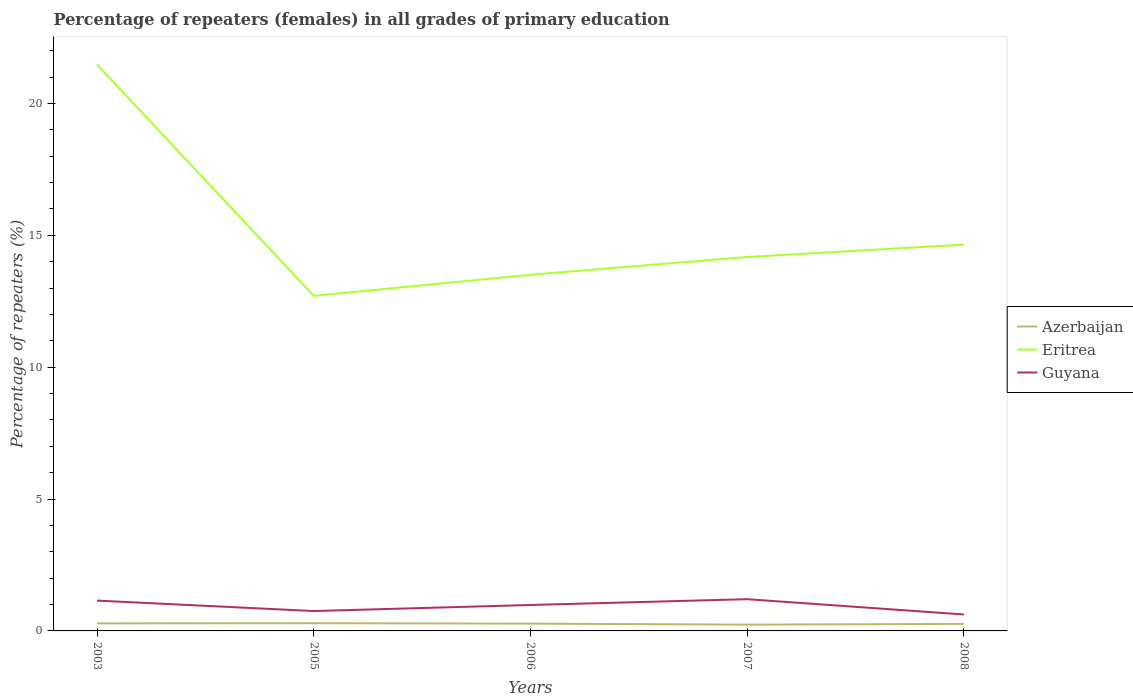How many different coloured lines are there?
Make the answer very short. 3. Is the number of lines equal to the number of legend labels?
Give a very brief answer. Yes. Across all years, what is the maximum percentage of repeaters (females) in Eritrea?
Keep it short and to the point. 12.7. In which year was the percentage of repeaters (females) in Azerbaijan maximum?
Provide a succinct answer. 2007. What is the total percentage of repeaters (females) in Azerbaijan in the graph?
Your answer should be very brief. -0.01. What is the difference between the highest and the second highest percentage of repeaters (females) in Azerbaijan?
Your response must be concise. 0.06. What is the difference between the highest and the lowest percentage of repeaters (females) in Eritrea?
Offer a very short reply. 1. How many lines are there?
Your response must be concise. 3. How many years are there in the graph?
Give a very brief answer. 5. Does the graph contain any zero values?
Provide a short and direct response. No. What is the title of the graph?
Your answer should be very brief. Percentage of repeaters (females) in all grades of primary education. What is the label or title of the X-axis?
Your answer should be very brief. Years. What is the label or title of the Y-axis?
Give a very brief answer. Percentage of repeaters (%). What is the Percentage of repeaters (%) of Azerbaijan in 2003?
Your answer should be compact. 0.29. What is the Percentage of repeaters (%) of Eritrea in 2003?
Offer a terse response. 21.47. What is the Percentage of repeaters (%) of Guyana in 2003?
Ensure brevity in your answer.  1.15. What is the Percentage of repeaters (%) of Azerbaijan in 2005?
Offer a very short reply. 0.29. What is the Percentage of repeaters (%) of Eritrea in 2005?
Offer a terse response. 12.7. What is the Percentage of repeaters (%) of Guyana in 2005?
Your answer should be compact. 0.75. What is the Percentage of repeaters (%) in Azerbaijan in 2006?
Your response must be concise. 0.28. What is the Percentage of repeaters (%) of Eritrea in 2006?
Offer a terse response. 13.5. What is the Percentage of repeaters (%) of Guyana in 2006?
Make the answer very short. 0.98. What is the Percentage of repeaters (%) of Azerbaijan in 2007?
Provide a succinct answer. 0.24. What is the Percentage of repeaters (%) of Eritrea in 2007?
Give a very brief answer. 14.18. What is the Percentage of repeaters (%) of Guyana in 2007?
Provide a succinct answer. 1.2. What is the Percentage of repeaters (%) in Azerbaijan in 2008?
Offer a very short reply. 0.27. What is the Percentage of repeaters (%) of Eritrea in 2008?
Your answer should be compact. 14.65. What is the Percentage of repeaters (%) in Guyana in 2008?
Keep it short and to the point. 0.62. Across all years, what is the maximum Percentage of repeaters (%) of Azerbaijan?
Keep it short and to the point. 0.29. Across all years, what is the maximum Percentage of repeaters (%) in Eritrea?
Provide a succinct answer. 21.47. Across all years, what is the maximum Percentage of repeaters (%) in Guyana?
Your answer should be compact. 1.2. Across all years, what is the minimum Percentage of repeaters (%) of Azerbaijan?
Give a very brief answer. 0.24. Across all years, what is the minimum Percentage of repeaters (%) in Eritrea?
Keep it short and to the point. 12.7. Across all years, what is the minimum Percentage of repeaters (%) in Guyana?
Offer a very short reply. 0.62. What is the total Percentage of repeaters (%) in Azerbaijan in the graph?
Provide a succinct answer. 1.36. What is the total Percentage of repeaters (%) of Eritrea in the graph?
Provide a short and direct response. 76.5. What is the total Percentage of repeaters (%) in Guyana in the graph?
Your response must be concise. 4.71. What is the difference between the Percentage of repeaters (%) of Azerbaijan in 2003 and that in 2005?
Make the answer very short. -0.01. What is the difference between the Percentage of repeaters (%) of Eritrea in 2003 and that in 2005?
Your answer should be very brief. 8.77. What is the difference between the Percentage of repeaters (%) in Guyana in 2003 and that in 2005?
Your answer should be very brief. 0.4. What is the difference between the Percentage of repeaters (%) of Azerbaijan in 2003 and that in 2006?
Make the answer very short. 0.01. What is the difference between the Percentage of repeaters (%) in Eritrea in 2003 and that in 2006?
Offer a terse response. 7.97. What is the difference between the Percentage of repeaters (%) of Guyana in 2003 and that in 2006?
Offer a terse response. 0.17. What is the difference between the Percentage of repeaters (%) in Azerbaijan in 2003 and that in 2007?
Give a very brief answer. 0.05. What is the difference between the Percentage of repeaters (%) in Eritrea in 2003 and that in 2007?
Keep it short and to the point. 7.29. What is the difference between the Percentage of repeaters (%) of Guyana in 2003 and that in 2007?
Ensure brevity in your answer.  -0.05. What is the difference between the Percentage of repeaters (%) in Azerbaijan in 2003 and that in 2008?
Your response must be concise. 0.02. What is the difference between the Percentage of repeaters (%) in Eritrea in 2003 and that in 2008?
Offer a terse response. 6.83. What is the difference between the Percentage of repeaters (%) in Guyana in 2003 and that in 2008?
Offer a terse response. 0.53. What is the difference between the Percentage of repeaters (%) of Azerbaijan in 2005 and that in 2006?
Your answer should be very brief. 0.02. What is the difference between the Percentage of repeaters (%) in Eritrea in 2005 and that in 2006?
Your answer should be compact. -0.8. What is the difference between the Percentage of repeaters (%) in Guyana in 2005 and that in 2006?
Your answer should be very brief. -0.23. What is the difference between the Percentage of repeaters (%) in Azerbaijan in 2005 and that in 2007?
Your answer should be very brief. 0.06. What is the difference between the Percentage of repeaters (%) in Eritrea in 2005 and that in 2007?
Ensure brevity in your answer.  -1.47. What is the difference between the Percentage of repeaters (%) of Guyana in 2005 and that in 2007?
Provide a succinct answer. -0.45. What is the difference between the Percentage of repeaters (%) of Azerbaijan in 2005 and that in 2008?
Make the answer very short. 0.03. What is the difference between the Percentage of repeaters (%) in Eritrea in 2005 and that in 2008?
Make the answer very short. -1.94. What is the difference between the Percentage of repeaters (%) in Guyana in 2005 and that in 2008?
Give a very brief answer. 0.13. What is the difference between the Percentage of repeaters (%) of Azerbaijan in 2006 and that in 2007?
Provide a succinct answer. 0.04. What is the difference between the Percentage of repeaters (%) of Eritrea in 2006 and that in 2007?
Your response must be concise. -0.67. What is the difference between the Percentage of repeaters (%) in Guyana in 2006 and that in 2007?
Provide a succinct answer. -0.22. What is the difference between the Percentage of repeaters (%) in Azerbaijan in 2006 and that in 2008?
Keep it short and to the point. 0.01. What is the difference between the Percentage of repeaters (%) of Eritrea in 2006 and that in 2008?
Your answer should be very brief. -1.14. What is the difference between the Percentage of repeaters (%) in Guyana in 2006 and that in 2008?
Keep it short and to the point. 0.36. What is the difference between the Percentage of repeaters (%) of Azerbaijan in 2007 and that in 2008?
Your answer should be very brief. -0.03. What is the difference between the Percentage of repeaters (%) in Eritrea in 2007 and that in 2008?
Your answer should be compact. -0.47. What is the difference between the Percentage of repeaters (%) of Guyana in 2007 and that in 2008?
Provide a succinct answer. 0.58. What is the difference between the Percentage of repeaters (%) of Azerbaijan in 2003 and the Percentage of repeaters (%) of Eritrea in 2005?
Give a very brief answer. -12.42. What is the difference between the Percentage of repeaters (%) in Azerbaijan in 2003 and the Percentage of repeaters (%) in Guyana in 2005?
Your answer should be compact. -0.47. What is the difference between the Percentage of repeaters (%) of Eritrea in 2003 and the Percentage of repeaters (%) of Guyana in 2005?
Your response must be concise. 20.72. What is the difference between the Percentage of repeaters (%) of Azerbaijan in 2003 and the Percentage of repeaters (%) of Eritrea in 2006?
Your response must be concise. -13.22. What is the difference between the Percentage of repeaters (%) of Azerbaijan in 2003 and the Percentage of repeaters (%) of Guyana in 2006?
Your answer should be very brief. -0.7. What is the difference between the Percentage of repeaters (%) in Eritrea in 2003 and the Percentage of repeaters (%) in Guyana in 2006?
Provide a short and direct response. 20.49. What is the difference between the Percentage of repeaters (%) in Azerbaijan in 2003 and the Percentage of repeaters (%) in Eritrea in 2007?
Make the answer very short. -13.89. What is the difference between the Percentage of repeaters (%) of Azerbaijan in 2003 and the Percentage of repeaters (%) of Guyana in 2007?
Provide a succinct answer. -0.92. What is the difference between the Percentage of repeaters (%) in Eritrea in 2003 and the Percentage of repeaters (%) in Guyana in 2007?
Give a very brief answer. 20.27. What is the difference between the Percentage of repeaters (%) of Azerbaijan in 2003 and the Percentage of repeaters (%) of Eritrea in 2008?
Ensure brevity in your answer.  -14.36. What is the difference between the Percentage of repeaters (%) in Azerbaijan in 2003 and the Percentage of repeaters (%) in Guyana in 2008?
Your response must be concise. -0.34. What is the difference between the Percentage of repeaters (%) in Eritrea in 2003 and the Percentage of repeaters (%) in Guyana in 2008?
Make the answer very short. 20.85. What is the difference between the Percentage of repeaters (%) of Azerbaijan in 2005 and the Percentage of repeaters (%) of Eritrea in 2006?
Your response must be concise. -13.21. What is the difference between the Percentage of repeaters (%) in Azerbaijan in 2005 and the Percentage of repeaters (%) in Guyana in 2006?
Your answer should be compact. -0.69. What is the difference between the Percentage of repeaters (%) in Eritrea in 2005 and the Percentage of repeaters (%) in Guyana in 2006?
Your answer should be compact. 11.72. What is the difference between the Percentage of repeaters (%) of Azerbaijan in 2005 and the Percentage of repeaters (%) of Eritrea in 2007?
Ensure brevity in your answer.  -13.88. What is the difference between the Percentage of repeaters (%) of Azerbaijan in 2005 and the Percentage of repeaters (%) of Guyana in 2007?
Offer a very short reply. -0.91. What is the difference between the Percentage of repeaters (%) of Eritrea in 2005 and the Percentage of repeaters (%) of Guyana in 2007?
Offer a very short reply. 11.5. What is the difference between the Percentage of repeaters (%) of Azerbaijan in 2005 and the Percentage of repeaters (%) of Eritrea in 2008?
Provide a succinct answer. -14.35. What is the difference between the Percentage of repeaters (%) of Azerbaijan in 2005 and the Percentage of repeaters (%) of Guyana in 2008?
Ensure brevity in your answer.  -0.33. What is the difference between the Percentage of repeaters (%) in Eritrea in 2005 and the Percentage of repeaters (%) in Guyana in 2008?
Offer a very short reply. 12.08. What is the difference between the Percentage of repeaters (%) of Azerbaijan in 2006 and the Percentage of repeaters (%) of Eritrea in 2007?
Keep it short and to the point. -13.9. What is the difference between the Percentage of repeaters (%) of Azerbaijan in 2006 and the Percentage of repeaters (%) of Guyana in 2007?
Provide a succinct answer. -0.93. What is the difference between the Percentage of repeaters (%) of Eritrea in 2006 and the Percentage of repeaters (%) of Guyana in 2007?
Keep it short and to the point. 12.3. What is the difference between the Percentage of repeaters (%) of Azerbaijan in 2006 and the Percentage of repeaters (%) of Eritrea in 2008?
Your answer should be compact. -14.37. What is the difference between the Percentage of repeaters (%) in Azerbaijan in 2006 and the Percentage of repeaters (%) in Guyana in 2008?
Ensure brevity in your answer.  -0.35. What is the difference between the Percentage of repeaters (%) of Eritrea in 2006 and the Percentage of repeaters (%) of Guyana in 2008?
Ensure brevity in your answer.  12.88. What is the difference between the Percentage of repeaters (%) in Azerbaijan in 2007 and the Percentage of repeaters (%) in Eritrea in 2008?
Your answer should be compact. -14.41. What is the difference between the Percentage of repeaters (%) of Azerbaijan in 2007 and the Percentage of repeaters (%) of Guyana in 2008?
Your answer should be compact. -0.39. What is the difference between the Percentage of repeaters (%) in Eritrea in 2007 and the Percentage of repeaters (%) in Guyana in 2008?
Your response must be concise. 13.55. What is the average Percentage of repeaters (%) in Azerbaijan per year?
Offer a very short reply. 0.27. What is the average Percentage of repeaters (%) in Eritrea per year?
Make the answer very short. 15.3. What is the average Percentage of repeaters (%) of Guyana per year?
Your answer should be compact. 0.94. In the year 2003, what is the difference between the Percentage of repeaters (%) in Azerbaijan and Percentage of repeaters (%) in Eritrea?
Give a very brief answer. -21.19. In the year 2003, what is the difference between the Percentage of repeaters (%) of Azerbaijan and Percentage of repeaters (%) of Guyana?
Provide a succinct answer. -0.86. In the year 2003, what is the difference between the Percentage of repeaters (%) of Eritrea and Percentage of repeaters (%) of Guyana?
Offer a terse response. 20.32. In the year 2005, what is the difference between the Percentage of repeaters (%) of Azerbaijan and Percentage of repeaters (%) of Eritrea?
Offer a very short reply. -12.41. In the year 2005, what is the difference between the Percentage of repeaters (%) in Azerbaijan and Percentage of repeaters (%) in Guyana?
Offer a terse response. -0.46. In the year 2005, what is the difference between the Percentage of repeaters (%) in Eritrea and Percentage of repeaters (%) in Guyana?
Provide a short and direct response. 11.95. In the year 2006, what is the difference between the Percentage of repeaters (%) in Azerbaijan and Percentage of repeaters (%) in Eritrea?
Offer a very short reply. -13.23. In the year 2006, what is the difference between the Percentage of repeaters (%) of Azerbaijan and Percentage of repeaters (%) of Guyana?
Your answer should be very brief. -0.71. In the year 2006, what is the difference between the Percentage of repeaters (%) in Eritrea and Percentage of repeaters (%) in Guyana?
Keep it short and to the point. 12.52. In the year 2007, what is the difference between the Percentage of repeaters (%) in Azerbaijan and Percentage of repeaters (%) in Eritrea?
Offer a terse response. -13.94. In the year 2007, what is the difference between the Percentage of repeaters (%) in Azerbaijan and Percentage of repeaters (%) in Guyana?
Provide a succinct answer. -0.97. In the year 2007, what is the difference between the Percentage of repeaters (%) of Eritrea and Percentage of repeaters (%) of Guyana?
Your answer should be very brief. 12.97. In the year 2008, what is the difference between the Percentage of repeaters (%) in Azerbaijan and Percentage of repeaters (%) in Eritrea?
Your response must be concise. -14.38. In the year 2008, what is the difference between the Percentage of repeaters (%) in Azerbaijan and Percentage of repeaters (%) in Guyana?
Provide a succinct answer. -0.36. In the year 2008, what is the difference between the Percentage of repeaters (%) in Eritrea and Percentage of repeaters (%) in Guyana?
Make the answer very short. 14.02. What is the ratio of the Percentage of repeaters (%) in Azerbaijan in 2003 to that in 2005?
Provide a succinct answer. 0.98. What is the ratio of the Percentage of repeaters (%) of Eritrea in 2003 to that in 2005?
Your answer should be very brief. 1.69. What is the ratio of the Percentage of repeaters (%) in Guyana in 2003 to that in 2005?
Your answer should be very brief. 1.53. What is the ratio of the Percentage of repeaters (%) of Azerbaijan in 2003 to that in 2006?
Offer a very short reply. 1.03. What is the ratio of the Percentage of repeaters (%) in Eritrea in 2003 to that in 2006?
Your response must be concise. 1.59. What is the ratio of the Percentage of repeaters (%) in Guyana in 2003 to that in 2006?
Offer a very short reply. 1.17. What is the ratio of the Percentage of repeaters (%) of Azerbaijan in 2003 to that in 2007?
Your answer should be compact. 1.2. What is the ratio of the Percentage of repeaters (%) in Eritrea in 2003 to that in 2007?
Your answer should be compact. 1.51. What is the ratio of the Percentage of repeaters (%) in Guyana in 2003 to that in 2007?
Ensure brevity in your answer.  0.96. What is the ratio of the Percentage of repeaters (%) of Azerbaijan in 2003 to that in 2008?
Your response must be concise. 1.07. What is the ratio of the Percentage of repeaters (%) of Eritrea in 2003 to that in 2008?
Keep it short and to the point. 1.47. What is the ratio of the Percentage of repeaters (%) of Guyana in 2003 to that in 2008?
Your response must be concise. 1.84. What is the ratio of the Percentage of repeaters (%) of Azerbaijan in 2005 to that in 2006?
Provide a succinct answer. 1.06. What is the ratio of the Percentage of repeaters (%) in Eritrea in 2005 to that in 2006?
Your answer should be very brief. 0.94. What is the ratio of the Percentage of repeaters (%) in Guyana in 2005 to that in 2006?
Provide a short and direct response. 0.77. What is the ratio of the Percentage of repeaters (%) in Azerbaijan in 2005 to that in 2007?
Offer a very short reply. 1.23. What is the ratio of the Percentage of repeaters (%) in Eritrea in 2005 to that in 2007?
Your answer should be very brief. 0.9. What is the ratio of the Percentage of repeaters (%) of Guyana in 2005 to that in 2007?
Your response must be concise. 0.63. What is the ratio of the Percentage of repeaters (%) of Azerbaijan in 2005 to that in 2008?
Offer a terse response. 1.1. What is the ratio of the Percentage of repeaters (%) of Eritrea in 2005 to that in 2008?
Keep it short and to the point. 0.87. What is the ratio of the Percentage of repeaters (%) of Guyana in 2005 to that in 2008?
Your answer should be very brief. 1.21. What is the ratio of the Percentage of repeaters (%) of Azerbaijan in 2006 to that in 2007?
Your response must be concise. 1.16. What is the ratio of the Percentage of repeaters (%) in Eritrea in 2006 to that in 2007?
Your response must be concise. 0.95. What is the ratio of the Percentage of repeaters (%) in Guyana in 2006 to that in 2007?
Ensure brevity in your answer.  0.82. What is the ratio of the Percentage of repeaters (%) of Azerbaijan in 2006 to that in 2008?
Ensure brevity in your answer.  1.04. What is the ratio of the Percentage of repeaters (%) in Eritrea in 2006 to that in 2008?
Provide a short and direct response. 0.92. What is the ratio of the Percentage of repeaters (%) of Guyana in 2006 to that in 2008?
Give a very brief answer. 1.58. What is the ratio of the Percentage of repeaters (%) of Azerbaijan in 2007 to that in 2008?
Ensure brevity in your answer.  0.89. What is the ratio of the Percentage of repeaters (%) of Eritrea in 2007 to that in 2008?
Offer a terse response. 0.97. What is the ratio of the Percentage of repeaters (%) of Guyana in 2007 to that in 2008?
Ensure brevity in your answer.  1.93. What is the difference between the highest and the second highest Percentage of repeaters (%) in Azerbaijan?
Offer a very short reply. 0.01. What is the difference between the highest and the second highest Percentage of repeaters (%) in Eritrea?
Your answer should be compact. 6.83. What is the difference between the highest and the second highest Percentage of repeaters (%) of Guyana?
Offer a very short reply. 0.05. What is the difference between the highest and the lowest Percentage of repeaters (%) in Azerbaijan?
Provide a short and direct response. 0.06. What is the difference between the highest and the lowest Percentage of repeaters (%) of Eritrea?
Ensure brevity in your answer.  8.77. What is the difference between the highest and the lowest Percentage of repeaters (%) in Guyana?
Your answer should be very brief. 0.58. 